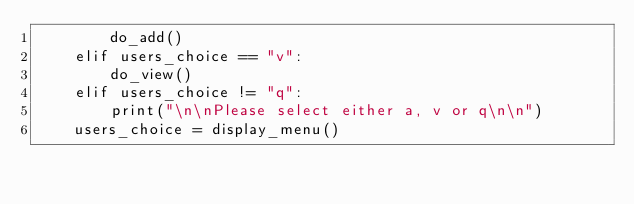Convert code to text. <code><loc_0><loc_0><loc_500><loc_500><_Python_>        do_add()
    elif users_choice == "v":
        do_view()
    elif users_choice != "q":
        print("\n\nPlease select either a, v or q\n\n")
    users_choice = display_menu()
</code> 